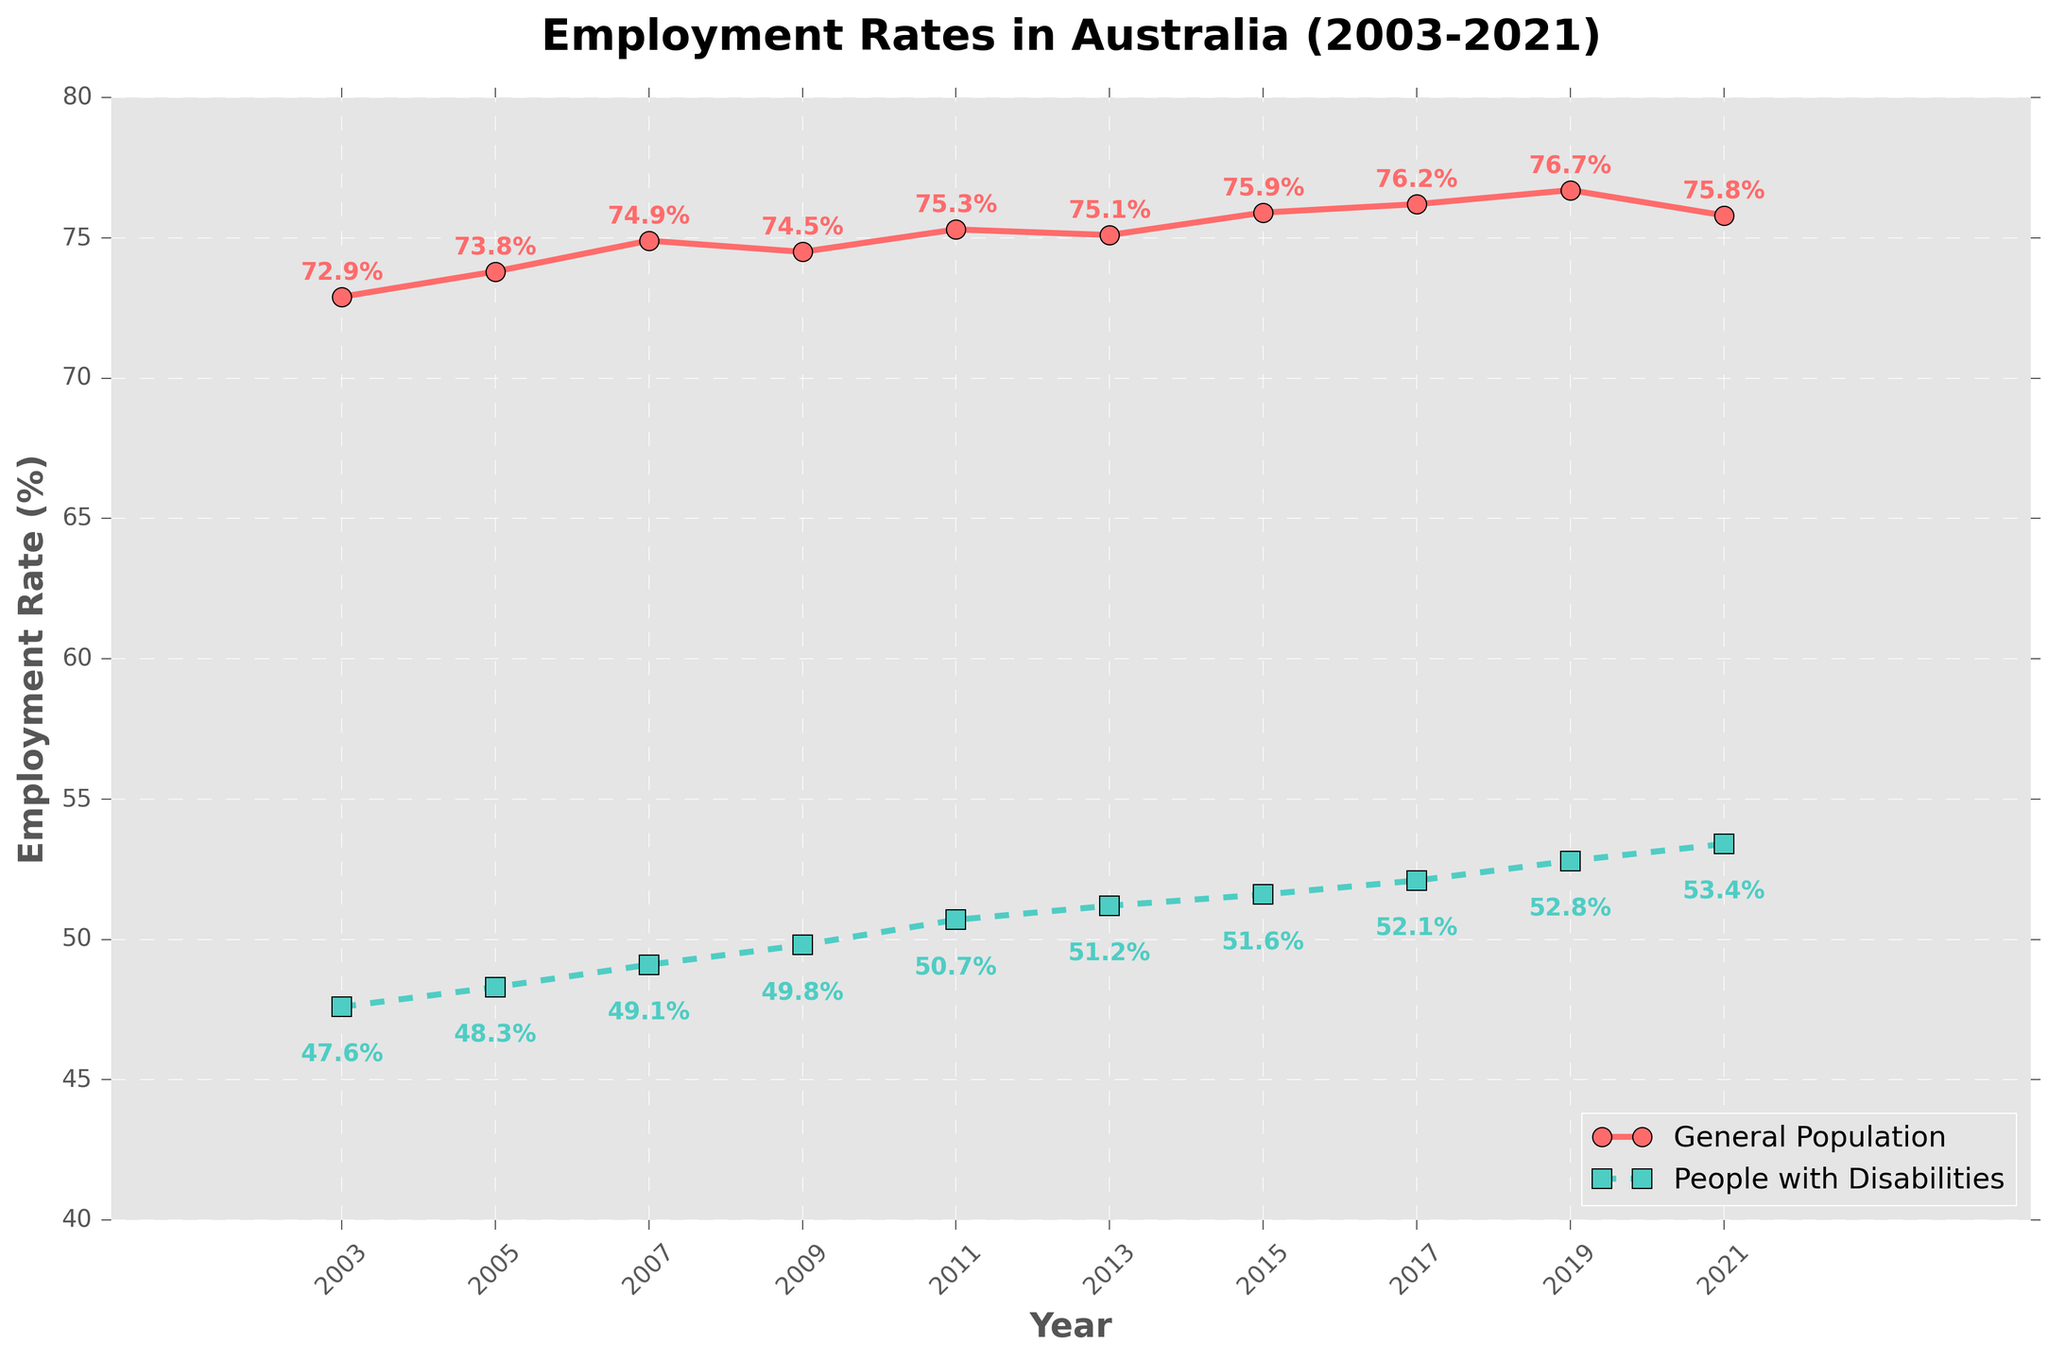What is the trend in the employment rate of the general population from 2003 to 2021? The employment rate of the general population shows an overall increasing trend from 72.9% in 2003 to 76.7% in 2019, followed by a slight decline to 75.8% in 2021.
Answer: Increasing What is the difference in the employment rates between people with disabilities and the general population in 2003 and 2021? In 2003, the employment rate for the general population was 72.9%, and for people with disabilities, it was 47.6%. In 2021, it was 75.8% for the general population and 53.4% for people with disabilities. The differences are 72.9% - 47.6% = 25.3% in 2003 and 75.8% - 53.4% = 22.4% in 2021.
Answer: 25.3%, 22.4% Which year has the highest employment rate for people with disabilities? By observing the plot, 2021 has the highest employment rate for people with disabilities at 53.4%.
Answer: 2021 How much did the employment rate for the general population change from 2009 to 2019? In 2009, the employment rate for the general population was 74.5%, and in 2019, it was 76.7%. The change is 76.7% - 74.5% = 2.2%.
Answer: 2.2% In which periods did the employment rate for people with disabilities increase the most? The plot shows that the employment rate for people with disabilities increased the most between 2009 (49.8%) and 2011 (50.7%), a change of 50.7% - 49.8% = 0.9%.
Answer: 2009-2011 How did the gap between the employment rates of the general population and people with disabilities change over the years? Observing the plot, the gap has generally decreased over the years. For instance, it was 25.3% in 2003 and decreased to 22.4% in 2021.
Answer: Decreased What are the two years where the employment rate for the general population decreased? By observing the plot, the employment rate for the general population decreased from 2007 (74.9%) to 2009 (74.5%) and from 2019 (76.7%) to 2021 (75.8%).
Answer: 2007-2009, 2019-2021 What is the employment rate for people with disabilities in 2015 and how does it compare to 2017? In 2015, the employment rate for people with disabilities was 51.6%, and in 2017, it was 52.1%. The increase is 52.1% - 51.6% = 0.5%.
Answer: 0.5% What percentage increase in employment rate for people with disabilities can be observed from 2003 to 2021? In 2003, the employment rate for people with disabilities was 47.6%, and in 2021, it was 53.4%. The percentage increase is ((53.4% - 47.6%) / 47.6%) * 100 ≈ 12.18%.
Answer: 12.18% What is the average employment rate for the general population over the years? The employment rates for the general population over the years are 72.9%, 73.8%, 74.9%, 74.5%, 75.3%, 75.1%, 75.9%, 76.2%, 76.7%, and 75.8%. The average is (72.9% + 73.8% + 74.9% + 74.5% + 75.3% + 75.1% + 75.9% + 76.2% + 76.7% + 75.8%) / 10 ≈ 74.9%.
Answer: 74.9% 